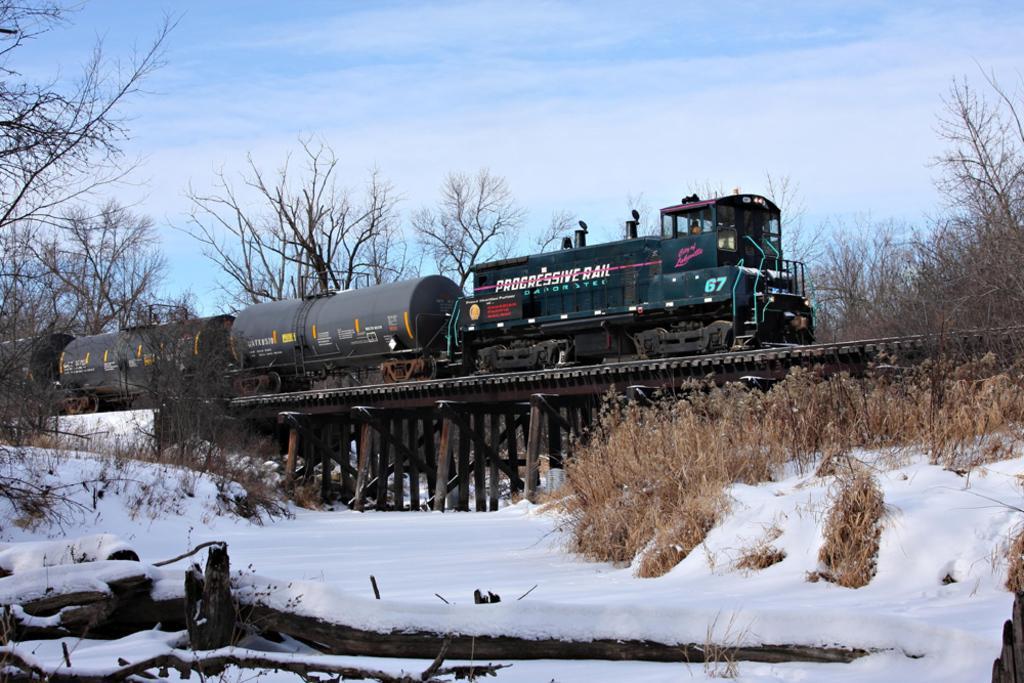How would you summarize this image in a sentence or two? In this image in front there are wooden branches. At the bottom of the image there is grass and there is snow on the surface. In the center of the image there is a train on the bridge. In the background of the image there are trees and sky. 